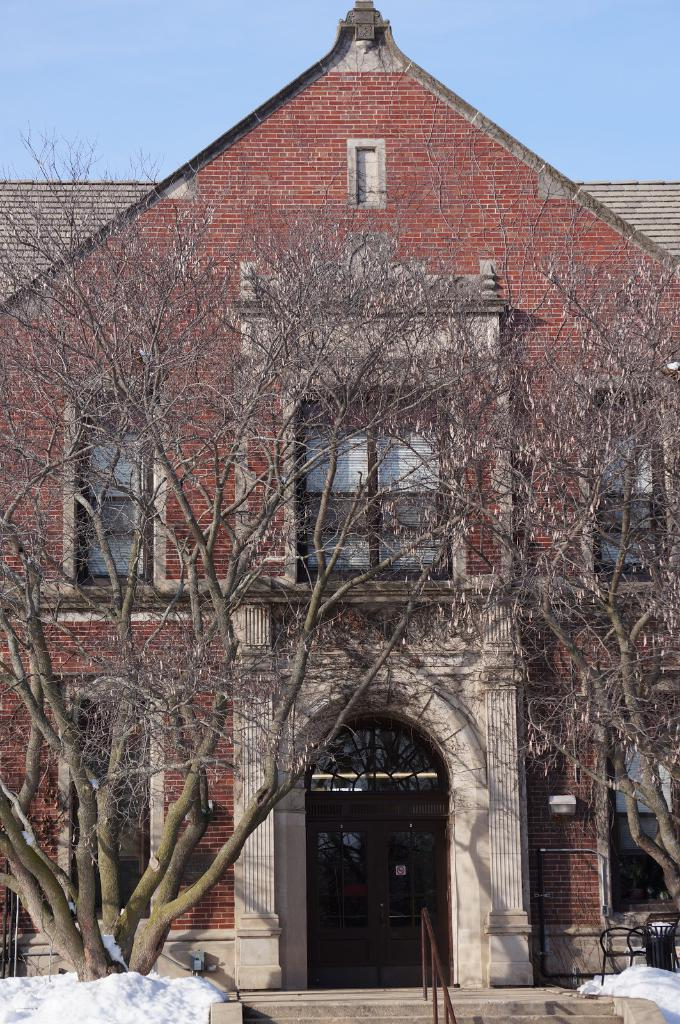What type of structure is visible in the image? There is a building in the image. What can be seen near the building? There is railing and chairs visible in the image. What is the condition of the ground in the image? There is snow on the ground in the image. What type of vegetation is present in the image? There are trees in the image. What is visible in the background of the image? The sky is visible in the image. What type of vest is being worn by the tree in the image? There are no vests present in the image, as trees do not wear clothing. 